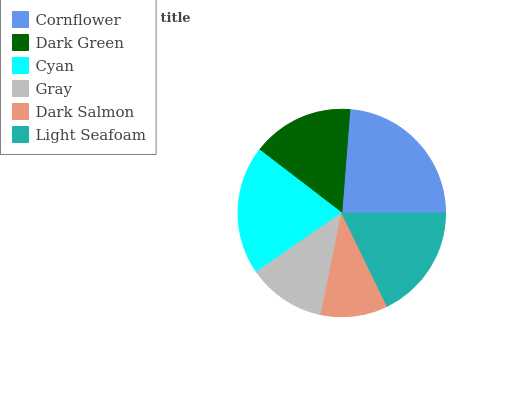Is Dark Salmon the minimum?
Answer yes or no. Yes. Is Cornflower the maximum?
Answer yes or no. Yes. Is Dark Green the minimum?
Answer yes or no. No. Is Dark Green the maximum?
Answer yes or no. No. Is Cornflower greater than Dark Green?
Answer yes or no. Yes. Is Dark Green less than Cornflower?
Answer yes or no. Yes. Is Dark Green greater than Cornflower?
Answer yes or no. No. Is Cornflower less than Dark Green?
Answer yes or no. No. Is Light Seafoam the high median?
Answer yes or no. Yes. Is Dark Green the low median?
Answer yes or no. Yes. Is Dark Salmon the high median?
Answer yes or no. No. Is Light Seafoam the low median?
Answer yes or no. No. 